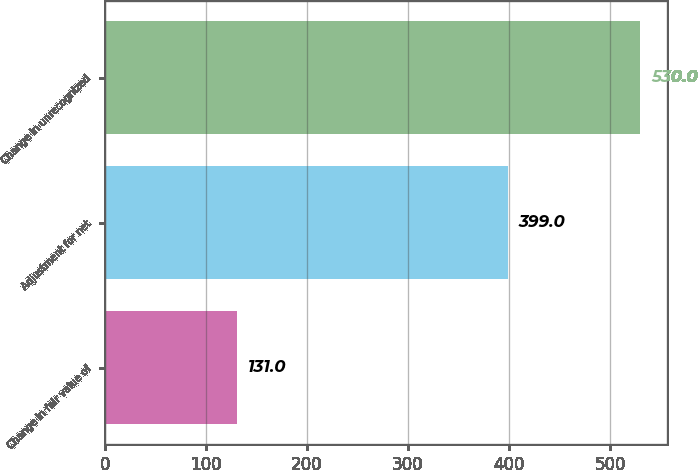Convert chart to OTSL. <chart><loc_0><loc_0><loc_500><loc_500><bar_chart><fcel>Change in fair value of<fcel>Adjustment for net<fcel>Change in unrecognized<nl><fcel>131<fcel>399<fcel>530<nl></chart> 